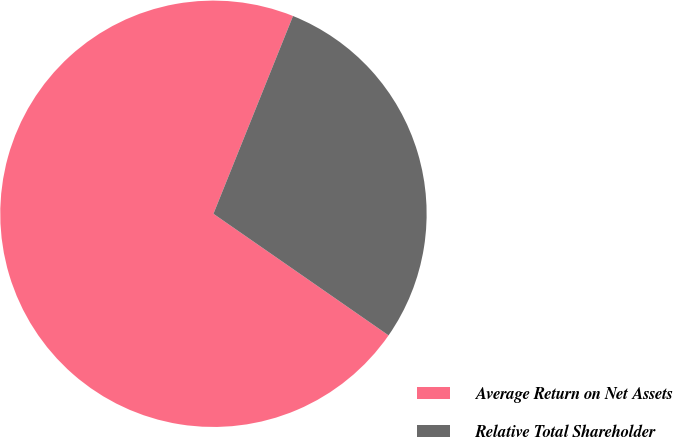Convert chart to OTSL. <chart><loc_0><loc_0><loc_500><loc_500><pie_chart><fcel>Average Return on Net Assets<fcel>Relative Total Shareholder<nl><fcel>71.43%<fcel>28.57%<nl></chart> 